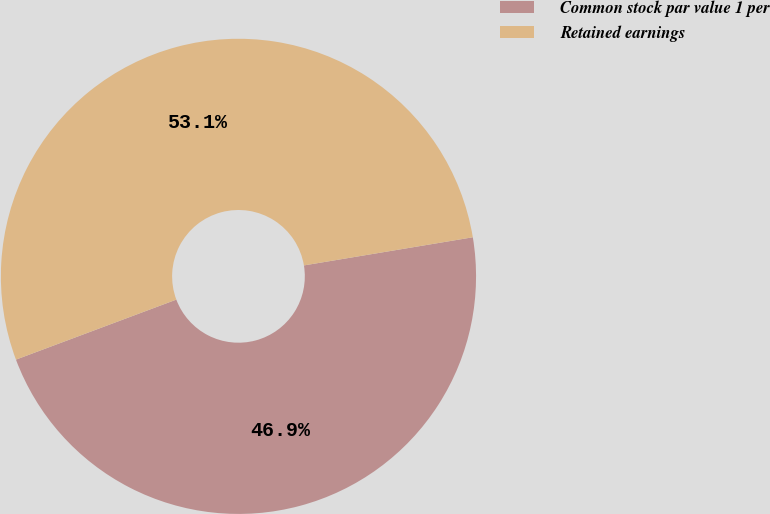Convert chart to OTSL. <chart><loc_0><loc_0><loc_500><loc_500><pie_chart><fcel>Common stock par value 1 per<fcel>Retained earnings<nl><fcel>46.93%<fcel>53.07%<nl></chart> 